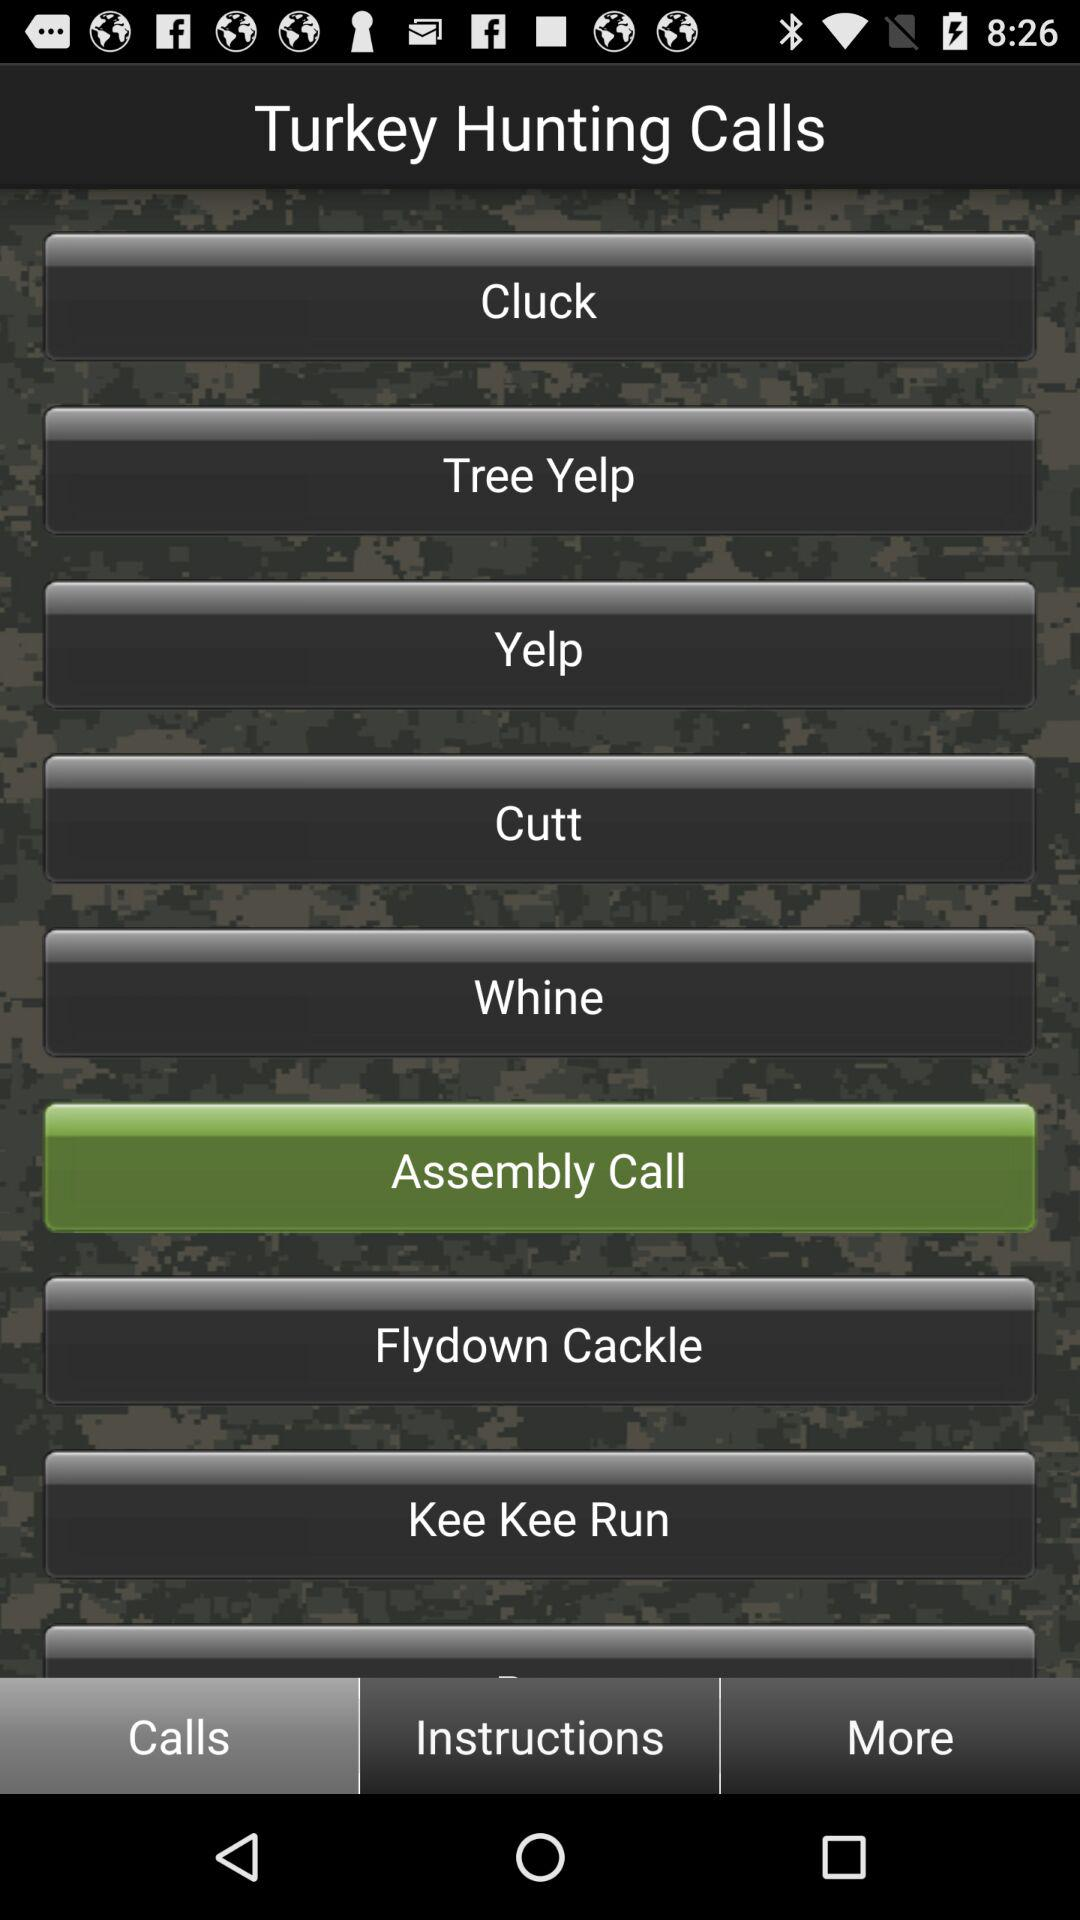How many steps are in the instructions?
When the provided information is insufficient, respond with <no answer>. <no answer> 